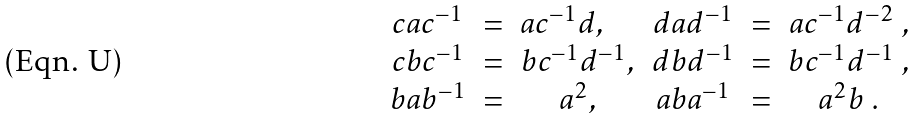<formula> <loc_0><loc_0><loc_500><loc_500>\begin{array} { c c c c c c } c a c ^ { - 1 } & = & a c ^ { - 1 } d , \quad & d a d ^ { - 1 } & = & a c ^ { - 1 } d ^ { - 2 } \ , \\ c b c ^ { - 1 } & = & b c ^ { - 1 } d ^ { - 1 } , & d b d ^ { - 1 } & = & b c ^ { - 1 } d ^ { - 1 } \ , \\ b a b ^ { - 1 } & = & a ^ { 2 } , & a b a ^ { - 1 } & = & a ^ { 2 } b \ . \end{array}</formula> 